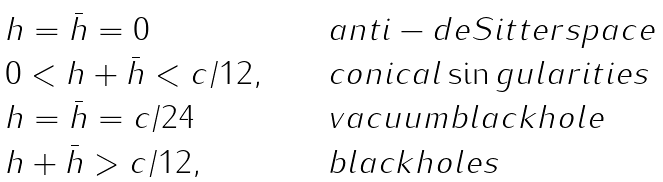Convert formula to latex. <formula><loc_0><loc_0><loc_500><loc_500>\begin{array} { l c l } h = \bar { h } = 0 & & a n t i - d e S i t t e r s p a c e \\ 0 < h + \bar { h } < c / 1 2 , \quad & & c o n i c a l \sin g u l a r i t i e s \\ h = \bar { h } = c / 2 4 & & v a c u u m b l a c k h o l e \\ h + \bar { h } > c / 1 2 , \quad & & b l a c k h o l e s \end{array}</formula> 